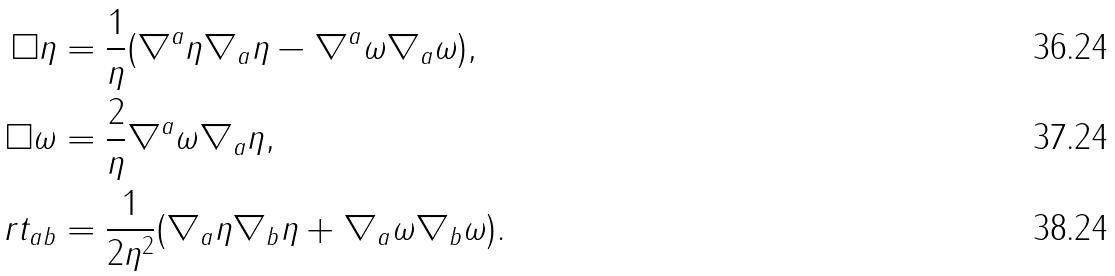<formula> <loc_0><loc_0><loc_500><loc_500>\Box \eta & = \frac { 1 } { \eta } ( \nabla ^ { a } \eta \nabla _ { a } \eta - \nabla ^ { a } \omega \nabla _ { a } \omega ) , \\ \Box \omega & = \frac { 2 } { \eta } \nabla ^ { a } \omega \nabla _ { a } \eta , \\ \ r t _ { a b } & = \frac { 1 } { 2 \eta ^ { 2 } } ( \nabla _ { a } \eta \nabla _ { b } \eta + \nabla _ { a } \omega \nabla _ { b } \omega ) .</formula> 